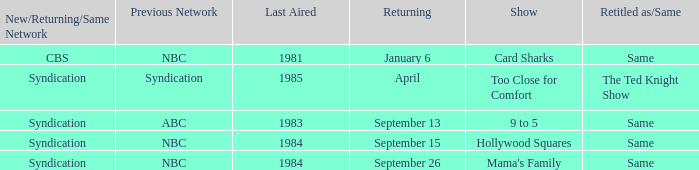What was the earliest aired show that's returning on September 13? 1983.0. 